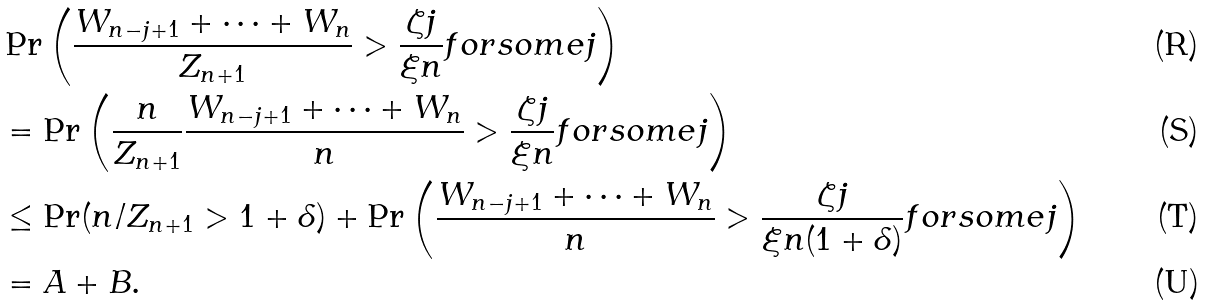Convert formula to latex. <formula><loc_0><loc_0><loc_500><loc_500>& \Pr \left ( \frac { W _ { n - j + 1 } + \dots + W _ { n } } { Z _ { n + 1 } } > \frac { \zeta j } { \xi n } f o r s o m e j \right ) \\ & = \Pr \left ( \frac { n } { Z _ { n + 1 } } \frac { W _ { n - j + 1 } + \dots + W _ { n } } { n } > \frac { \zeta j } { \xi n } f o r s o m e j \right ) \\ & \leq \Pr ( n / Z _ { n + 1 } > 1 + \delta ) + \Pr \left ( \frac { W _ { n - j + 1 } + \dots + W _ { n } } { n } > \frac { \zeta j } { \xi n ( 1 + \delta ) } f o r s o m e j \right ) \\ & = A + B .</formula> 